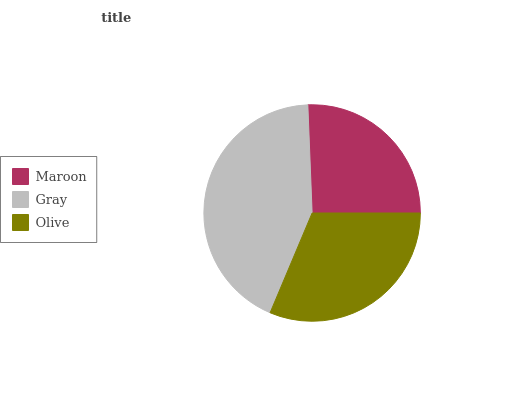Is Maroon the minimum?
Answer yes or no. Yes. Is Gray the maximum?
Answer yes or no. Yes. Is Olive the minimum?
Answer yes or no. No. Is Olive the maximum?
Answer yes or no. No. Is Gray greater than Olive?
Answer yes or no. Yes. Is Olive less than Gray?
Answer yes or no. Yes. Is Olive greater than Gray?
Answer yes or no. No. Is Gray less than Olive?
Answer yes or no. No. Is Olive the high median?
Answer yes or no. Yes. Is Olive the low median?
Answer yes or no. Yes. Is Gray the high median?
Answer yes or no. No. Is Maroon the low median?
Answer yes or no. No. 